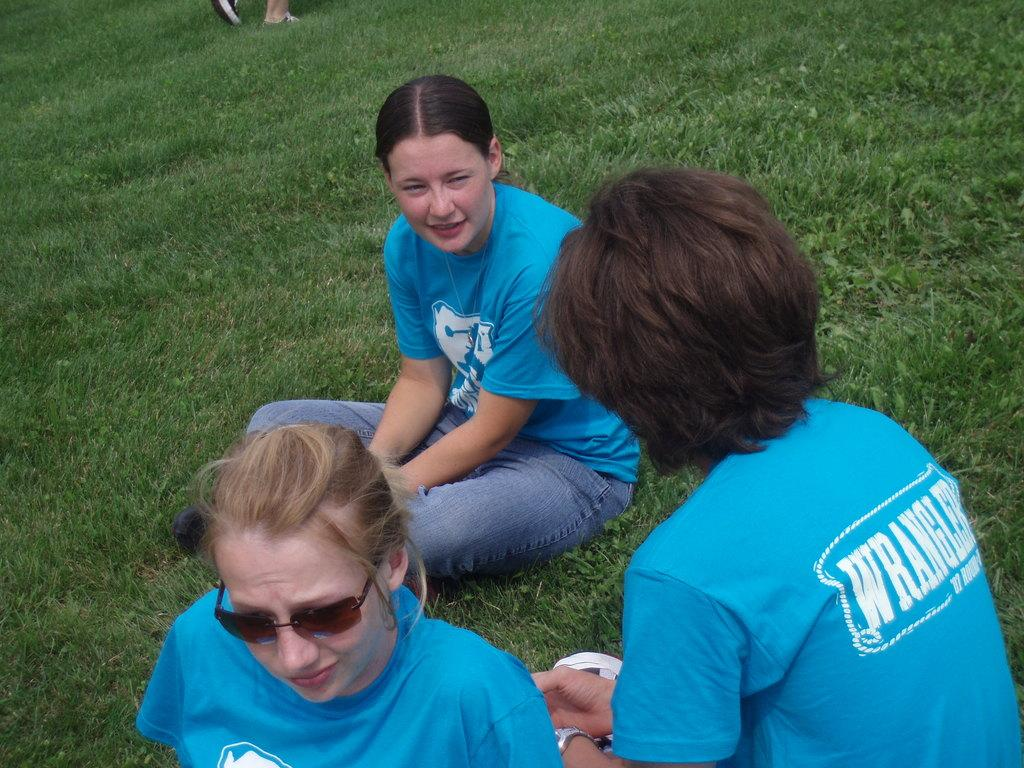Who or what can be seen in the image? There are people in the image. What type of terrain is visible in the image? There is grass in the image. Can you describe the position of a person in the image? The legs of a person are visible at the top of the image. What type of curve can be seen in the image? There is no curve present in the image. Is there a baby visible in the image? The provided facts do not mention a baby, so we cannot determine if one is present in the image. 